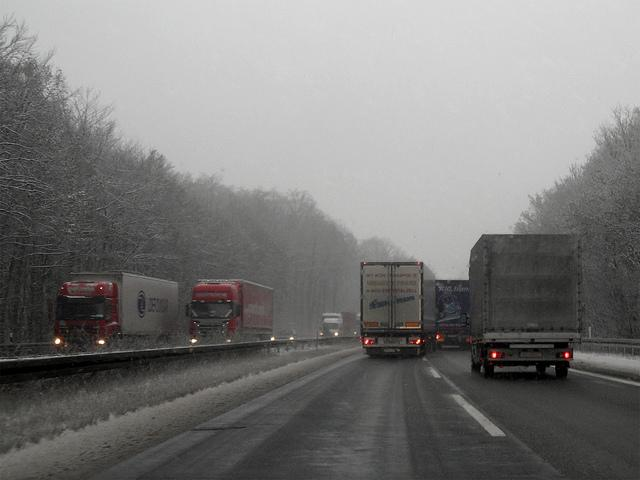What is blowing in the wind? snow 